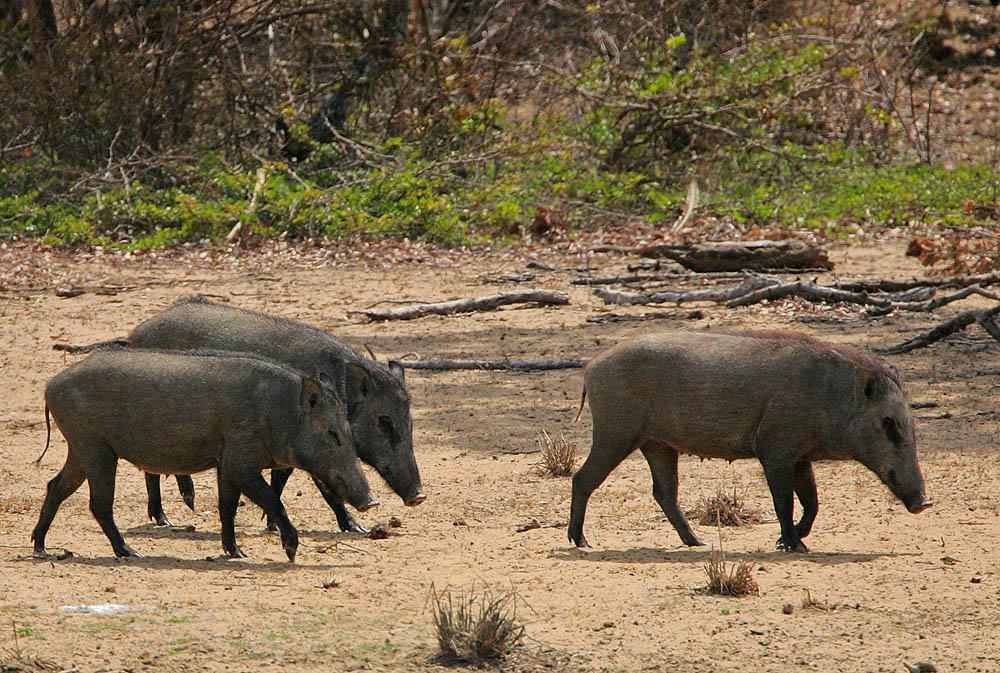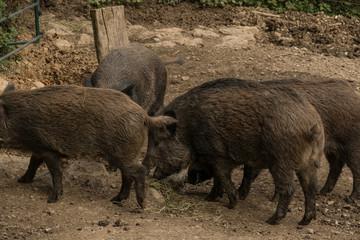The first image is the image on the left, the second image is the image on the right. Analyze the images presented: Is the assertion "There is black mother boar laying the dirt with at least six nursing piglets at her belly." valid? Answer yes or no. No. 